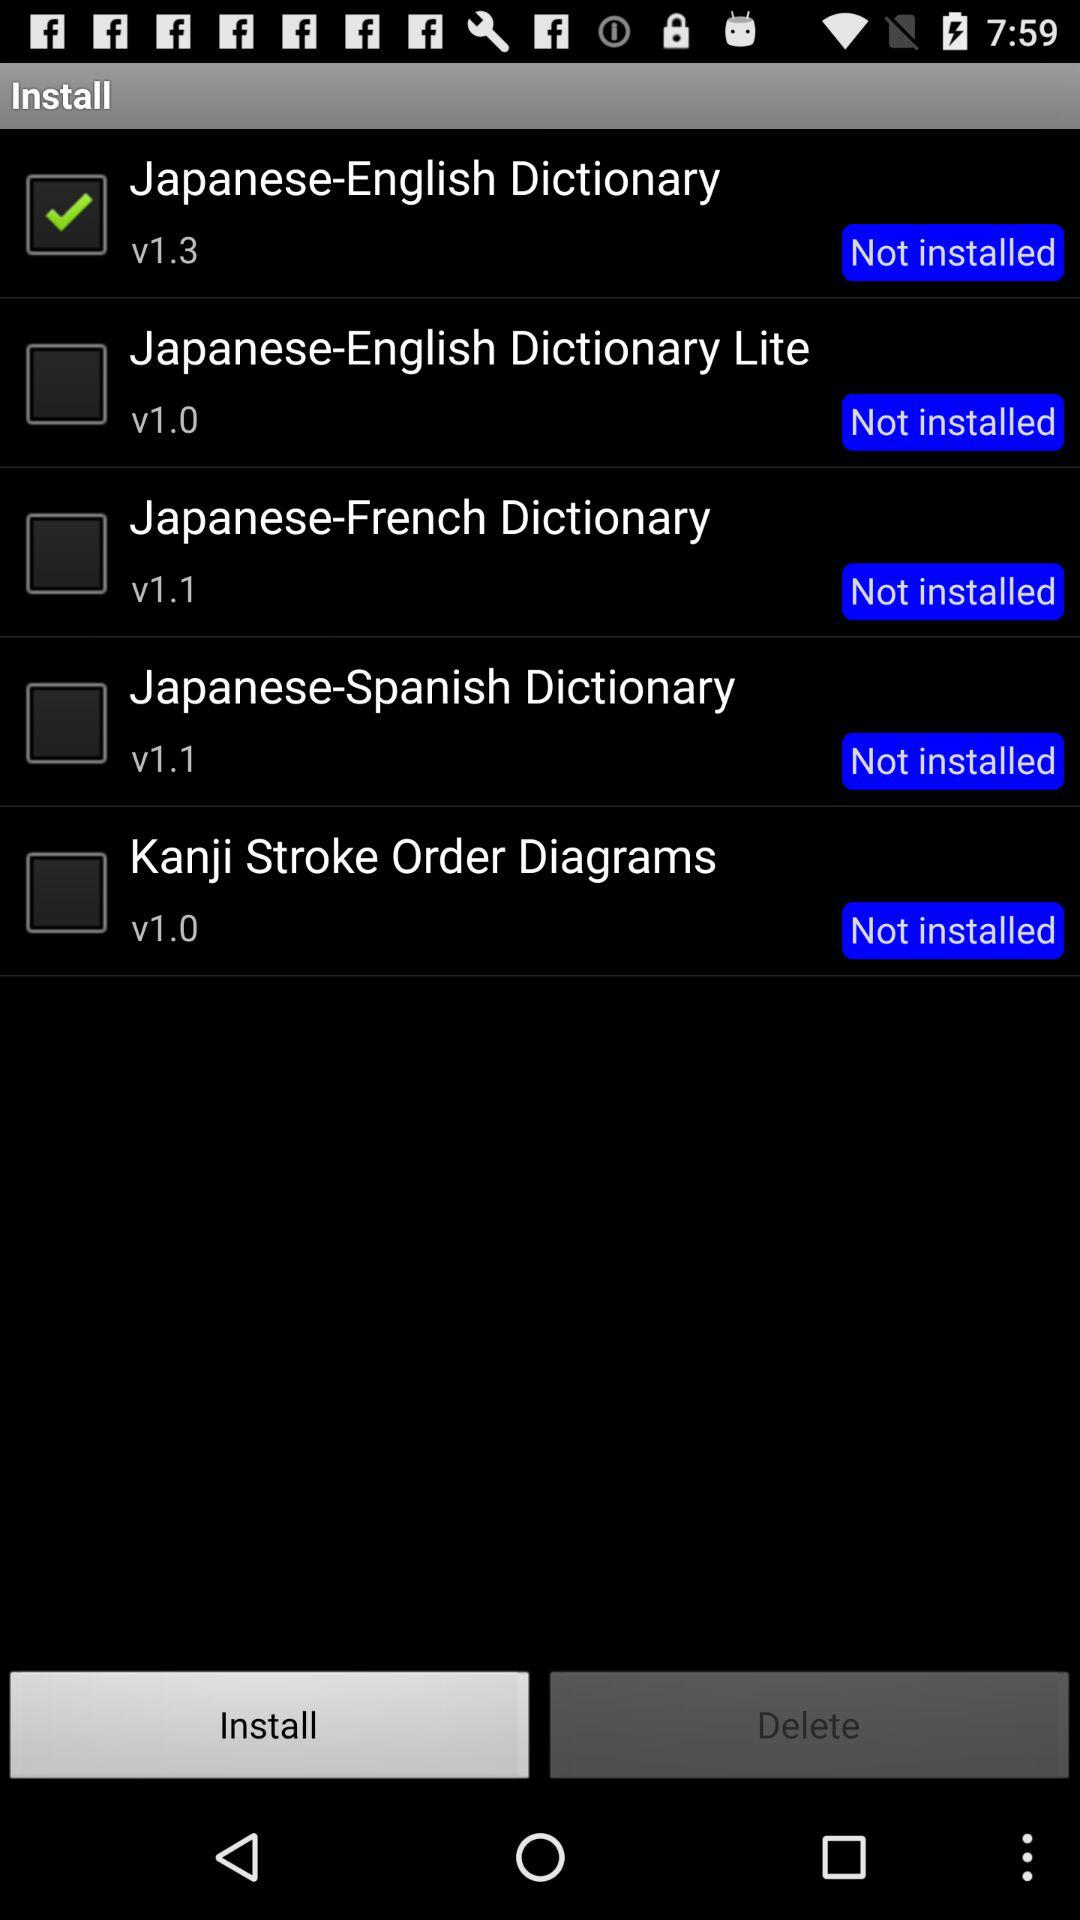What is the application version of the "Japanese-Spanish Dictionary"? The version of the "Japanese-Spanish Dictionary" is v1.1. 